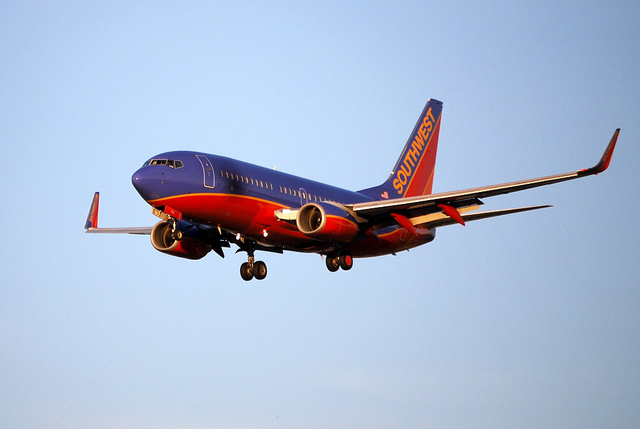Read all the text in this image. SOUTHWEST 